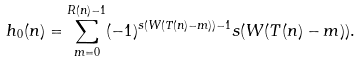<formula> <loc_0><loc_0><loc_500><loc_500>h _ { 0 } ( n ) = \sum _ { m = 0 } ^ { R ( n ) - 1 } ( - 1 ) ^ { s ( W ( T ( n ) - m ) ) - 1 } s ( W ( T ( n ) - m ) ) .</formula> 